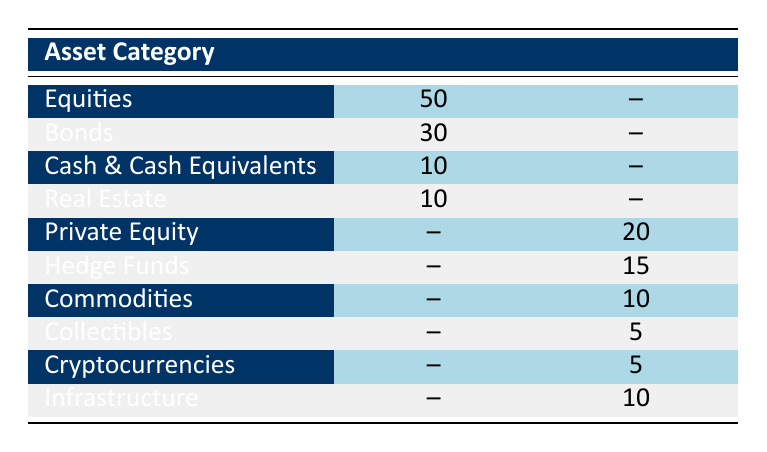What is the allocation percentage for equities in traditional investments? The table indicates that the allocation percentage for equities in traditional investments is 50%.
Answer: 50 How much of traditional investments is allocated to bonds? According to the table, traditional investments allocate 30% to bonds.
Answer: 30 Is there any allocation for collectibles in traditional investments? The table shows that there is no allocation for collectibles in traditional investments, as that category is only listed under alternative investments.
Answer: No What is the total allocation percentage for alternative investments? To find the total allocation percentage for alternative investments, we sum the percentages of Private Equity (20%), Hedge Funds (15%), Commodities (10%), Collectibles (5%), Cryptocurrencies (5%), and Infrastructure (10%). This gives us 20 + 15 + 10 + 5 + 5 + 10 = 75%.
Answer: 75 Which investment category has the highest percentage in traditional investments? The data shows that equities have the highest allocation percentage in traditional investments, which is 50%.
Answer: Equities What is the difference in percentage allocation between traditional and alternative investments for hedge funds? The allocation for hedge funds in alternative investments is 15% while there is no allocation in traditional investments. Therefore, the difference is 15% - 0% = 15%.
Answer: 15 Are there any asset categories that appear in both traditional and alternative investments? The table indicates that there are no asset categories that appear in both traditional and alternative investments, as each category is exclusive to one type.
Answer: No What is the average allocation percentage across all categories in traditional investments? The allocation percentages for traditional investments are 50% (Equities), 30% (Bonds), 10% (Cash & Cash Equivalents), and 10% (Real Estate). Adding these gives us 50 + 30 + 10 + 10 = 100%. Dividing by the number of categories (4) gives an average of 100/4 = 25%.
Answer: 25 How many categories have an allocation of 5% or lower in alternative investments? The categories in alternative investments with an allocation of 5% or lower are collectibles and cryptocurrencies. There are two categories that meet this criterion.
Answer: 2 